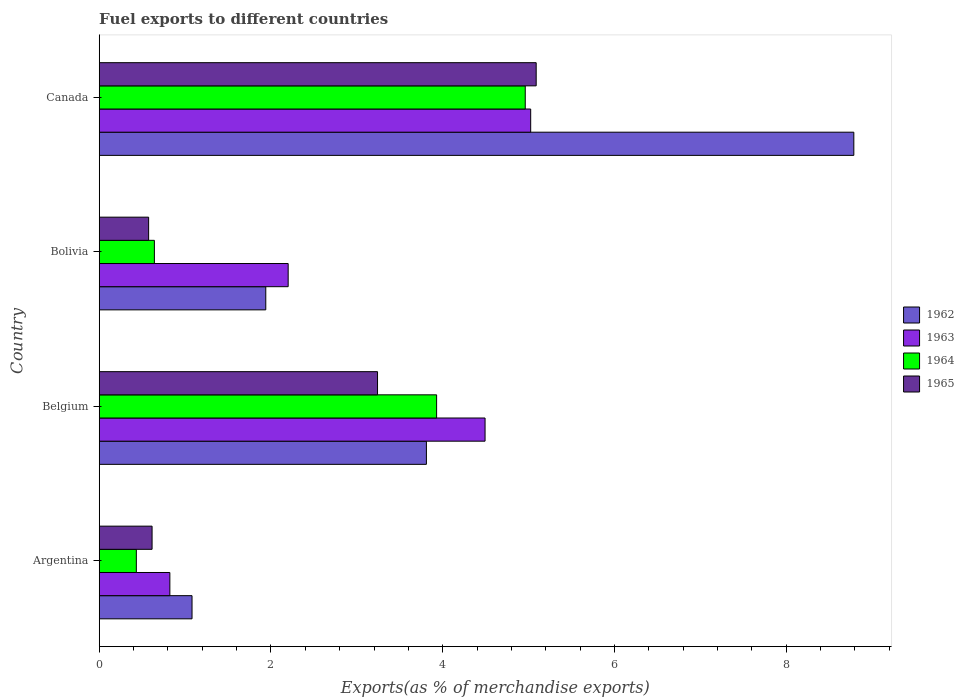How many different coloured bars are there?
Keep it short and to the point. 4. How many groups of bars are there?
Offer a very short reply. 4. Are the number of bars per tick equal to the number of legend labels?
Your answer should be compact. Yes. Are the number of bars on each tick of the Y-axis equal?
Ensure brevity in your answer.  Yes. What is the label of the 1st group of bars from the top?
Give a very brief answer. Canada. What is the percentage of exports to different countries in 1963 in Argentina?
Ensure brevity in your answer.  0.82. Across all countries, what is the maximum percentage of exports to different countries in 1962?
Keep it short and to the point. 8.79. Across all countries, what is the minimum percentage of exports to different countries in 1965?
Give a very brief answer. 0.58. In which country was the percentage of exports to different countries in 1963 minimum?
Provide a short and direct response. Argentina. What is the total percentage of exports to different countries in 1965 in the graph?
Your response must be concise. 9.52. What is the difference between the percentage of exports to different countries in 1963 in Belgium and that in Bolivia?
Your response must be concise. 2.29. What is the difference between the percentage of exports to different countries in 1963 in Bolivia and the percentage of exports to different countries in 1962 in Belgium?
Keep it short and to the point. -1.61. What is the average percentage of exports to different countries in 1962 per country?
Your answer should be very brief. 3.9. What is the difference between the percentage of exports to different countries in 1962 and percentage of exports to different countries in 1965 in Belgium?
Offer a terse response. 0.57. In how many countries, is the percentage of exports to different countries in 1962 greater than 3.2 %?
Keep it short and to the point. 2. What is the ratio of the percentage of exports to different countries in 1962 in Bolivia to that in Canada?
Your answer should be very brief. 0.22. What is the difference between the highest and the second highest percentage of exports to different countries in 1965?
Provide a short and direct response. 1.85. What is the difference between the highest and the lowest percentage of exports to different countries in 1962?
Provide a succinct answer. 7.71. In how many countries, is the percentage of exports to different countries in 1963 greater than the average percentage of exports to different countries in 1963 taken over all countries?
Offer a terse response. 2. Is it the case that in every country, the sum of the percentage of exports to different countries in 1965 and percentage of exports to different countries in 1963 is greater than the sum of percentage of exports to different countries in 1962 and percentage of exports to different countries in 1964?
Offer a terse response. No. What does the 2nd bar from the top in Belgium represents?
Your answer should be very brief. 1964. What does the 4th bar from the bottom in Belgium represents?
Your answer should be very brief. 1965. Is it the case that in every country, the sum of the percentage of exports to different countries in 1964 and percentage of exports to different countries in 1965 is greater than the percentage of exports to different countries in 1962?
Your response must be concise. No. How many bars are there?
Offer a terse response. 16. Are the values on the major ticks of X-axis written in scientific E-notation?
Provide a short and direct response. No. Where does the legend appear in the graph?
Provide a succinct answer. Center right. How many legend labels are there?
Your answer should be very brief. 4. What is the title of the graph?
Give a very brief answer. Fuel exports to different countries. Does "1961" appear as one of the legend labels in the graph?
Provide a short and direct response. No. What is the label or title of the X-axis?
Offer a very short reply. Exports(as % of merchandise exports). What is the label or title of the Y-axis?
Provide a short and direct response. Country. What is the Exports(as % of merchandise exports) in 1962 in Argentina?
Your answer should be very brief. 1.08. What is the Exports(as % of merchandise exports) of 1963 in Argentina?
Your answer should be very brief. 0.82. What is the Exports(as % of merchandise exports) of 1964 in Argentina?
Make the answer very short. 0.43. What is the Exports(as % of merchandise exports) in 1965 in Argentina?
Your answer should be compact. 0.62. What is the Exports(as % of merchandise exports) of 1962 in Belgium?
Give a very brief answer. 3.81. What is the Exports(as % of merchandise exports) in 1963 in Belgium?
Offer a terse response. 4.49. What is the Exports(as % of merchandise exports) in 1964 in Belgium?
Make the answer very short. 3.93. What is the Exports(as % of merchandise exports) in 1965 in Belgium?
Make the answer very short. 3.24. What is the Exports(as % of merchandise exports) of 1962 in Bolivia?
Keep it short and to the point. 1.94. What is the Exports(as % of merchandise exports) of 1963 in Bolivia?
Offer a terse response. 2.2. What is the Exports(as % of merchandise exports) of 1964 in Bolivia?
Keep it short and to the point. 0.64. What is the Exports(as % of merchandise exports) in 1965 in Bolivia?
Offer a terse response. 0.58. What is the Exports(as % of merchandise exports) of 1962 in Canada?
Your answer should be very brief. 8.79. What is the Exports(as % of merchandise exports) of 1963 in Canada?
Your answer should be very brief. 5.02. What is the Exports(as % of merchandise exports) in 1964 in Canada?
Your answer should be very brief. 4.96. What is the Exports(as % of merchandise exports) of 1965 in Canada?
Ensure brevity in your answer.  5.09. Across all countries, what is the maximum Exports(as % of merchandise exports) of 1962?
Ensure brevity in your answer.  8.79. Across all countries, what is the maximum Exports(as % of merchandise exports) in 1963?
Offer a very short reply. 5.02. Across all countries, what is the maximum Exports(as % of merchandise exports) in 1964?
Make the answer very short. 4.96. Across all countries, what is the maximum Exports(as % of merchandise exports) of 1965?
Offer a terse response. 5.09. Across all countries, what is the minimum Exports(as % of merchandise exports) of 1962?
Give a very brief answer. 1.08. Across all countries, what is the minimum Exports(as % of merchandise exports) in 1963?
Provide a short and direct response. 0.82. Across all countries, what is the minimum Exports(as % of merchandise exports) in 1964?
Provide a short and direct response. 0.43. Across all countries, what is the minimum Exports(as % of merchandise exports) in 1965?
Provide a short and direct response. 0.58. What is the total Exports(as % of merchandise exports) in 1962 in the graph?
Make the answer very short. 15.62. What is the total Exports(as % of merchandise exports) in 1963 in the graph?
Ensure brevity in your answer.  12.54. What is the total Exports(as % of merchandise exports) of 1964 in the graph?
Your answer should be compact. 9.97. What is the total Exports(as % of merchandise exports) in 1965 in the graph?
Ensure brevity in your answer.  9.52. What is the difference between the Exports(as % of merchandise exports) in 1962 in Argentina and that in Belgium?
Keep it short and to the point. -2.73. What is the difference between the Exports(as % of merchandise exports) of 1963 in Argentina and that in Belgium?
Provide a short and direct response. -3.67. What is the difference between the Exports(as % of merchandise exports) in 1964 in Argentina and that in Belgium?
Your response must be concise. -3.5. What is the difference between the Exports(as % of merchandise exports) in 1965 in Argentina and that in Belgium?
Your answer should be compact. -2.63. What is the difference between the Exports(as % of merchandise exports) in 1962 in Argentina and that in Bolivia?
Keep it short and to the point. -0.86. What is the difference between the Exports(as % of merchandise exports) in 1963 in Argentina and that in Bolivia?
Offer a very short reply. -1.38. What is the difference between the Exports(as % of merchandise exports) in 1964 in Argentina and that in Bolivia?
Provide a short and direct response. -0.21. What is the difference between the Exports(as % of merchandise exports) of 1965 in Argentina and that in Bolivia?
Provide a short and direct response. 0.04. What is the difference between the Exports(as % of merchandise exports) of 1962 in Argentina and that in Canada?
Your answer should be compact. -7.71. What is the difference between the Exports(as % of merchandise exports) of 1963 in Argentina and that in Canada?
Give a very brief answer. -4.2. What is the difference between the Exports(as % of merchandise exports) of 1964 in Argentina and that in Canada?
Ensure brevity in your answer.  -4.53. What is the difference between the Exports(as % of merchandise exports) in 1965 in Argentina and that in Canada?
Keep it short and to the point. -4.47. What is the difference between the Exports(as % of merchandise exports) in 1962 in Belgium and that in Bolivia?
Offer a very short reply. 1.87. What is the difference between the Exports(as % of merchandise exports) in 1963 in Belgium and that in Bolivia?
Provide a succinct answer. 2.29. What is the difference between the Exports(as % of merchandise exports) in 1964 in Belgium and that in Bolivia?
Provide a short and direct response. 3.29. What is the difference between the Exports(as % of merchandise exports) of 1965 in Belgium and that in Bolivia?
Ensure brevity in your answer.  2.67. What is the difference between the Exports(as % of merchandise exports) of 1962 in Belgium and that in Canada?
Offer a terse response. -4.98. What is the difference between the Exports(as % of merchandise exports) of 1963 in Belgium and that in Canada?
Ensure brevity in your answer.  -0.53. What is the difference between the Exports(as % of merchandise exports) of 1964 in Belgium and that in Canada?
Provide a succinct answer. -1.03. What is the difference between the Exports(as % of merchandise exports) of 1965 in Belgium and that in Canada?
Give a very brief answer. -1.85. What is the difference between the Exports(as % of merchandise exports) in 1962 in Bolivia and that in Canada?
Give a very brief answer. -6.85. What is the difference between the Exports(as % of merchandise exports) in 1963 in Bolivia and that in Canada?
Offer a terse response. -2.82. What is the difference between the Exports(as % of merchandise exports) in 1964 in Bolivia and that in Canada?
Your answer should be compact. -4.32. What is the difference between the Exports(as % of merchandise exports) of 1965 in Bolivia and that in Canada?
Provide a short and direct response. -4.51. What is the difference between the Exports(as % of merchandise exports) of 1962 in Argentina and the Exports(as % of merchandise exports) of 1963 in Belgium?
Your answer should be very brief. -3.41. What is the difference between the Exports(as % of merchandise exports) in 1962 in Argentina and the Exports(as % of merchandise exports) in 1964 in Belgium?
Your answer should be very brief. -2.85. What is the difference between the Exports(as % of merchandise exports) of 1962 in Argentina and the Exports(as % of merchandise exports) of 1965 in Belgium?
Provide a short and direct response. -2.16. What is the difference between the Exports(as % of merchandise exports) of 1963 in Argentina and the Exports(as % of merchandise exports) of 1964 in Belgium?
Provide a short and direct response. -3.11. What is the difference between the Exports(as % of merchandise exports) of 1963 in Argentina and the Exports(as % of merchandise exports) of 1965 in Belgium?
Provide a succinct answer. -2.42. What is the difference between the Exports(as % of merchandise exports) in 1964 in Argentina and the Exports(as % of merchandise exports) in 1965 in Belgium?
Give a very brief answer. -2.81. What is the difference between the Exports(as % of merchandise exports) of 1962 in Argentina and the Exports(as % of merchandise exports) of 1963 in Bolivia?
Provide a short and direct response. -1.12. What is the difference between the Exports(as % of merchandise exports) of 1962 in Argentina and the Exports(as % of merchandise exports) of 1964 in Bolivia?
Offer a very short reply. 0.44. What is the difference between the Exports(as % of merchandise exports) in 1962 in Argentina and the Exports(as % of merchandise exports) in 1965 in Bolivia?
Your answer should be compact. 0.51. What is the difference between the Exports(as % of merchandise exports) in 1963 in Argentina and the Exports(as % of merchandise exports) in 1964 in Bolivia?
Provide a succinct answer. 0.18. What is the difference between the Exports(as % of merchandise exports) of 1963 in Argentina and the Exports(as % of merchandise exports) of 1965 in Bolivia?
Give a very brief answer. 0.25. What is the difference between the Exports(as % of merchandise exports) of 1964 in Argentina and the Exports(as % of merchandise exports) of 1965 in Bolivia?
Keep it short and to the point. -0.14. What is the difference between the Exports(as % of merchandise exports) in 1962 in Argentina and the Exports(as % of merchandise exports) in 1963 in Canada?
Your answer should be very brief. -3.94. What is the difference between the Exports(as % of merchandise exports) in 1962 in Argentina and the Exports(as % of merchandise exports) in 1964 in Canada?
Ensure brevity in your answer.  -3.88. What is the difference between the Exports(as % of merchandise exports) of 1962 in Argentina and the Exports(as % of merchandise exports) of 1965 in Canada?
Offer a very short reply. -4.01. What is the difference between the Exports(as % of merchandise exports) in 1963 in Argentina and the Exports(as % of merchandise exports) in 1964 in Canada?
Offer a very short reply. -4.14. What is the difference between the Exports(as % of merchandise exports) in 1963 in Argentina and the Exports(as % of merchandise exports) in 1965 in Canada?
Give a very brief answer. -4.27. What is the difference between the Exports(as % of merchandise exports) in 1964 in Argentina and the Exports(as % of merchandise exports) in 1965 in Canada?
Provide a succinct answer. -4.66. What is the difference between the Exports(as % of merchandise exports) in 1962 in Belgium and the Exports(as % of merchandise exports) in 1963 in Bolivia?
Provide a succinct answer. 1.61. What is the difference between the Exports(as % of merchandise exports) of 1962 in Belgium and the Exports(as % of merchandise exports) of 1964 in Bolivia?
Provide a short and direct response. 3.17. What is the difference between the Exports(as % of merchandise exports) in 1962 in Belgium and the Exports(as % of merchandise exports) in 1965 in Bolivia?
Your answer should be very brief. 3.23. What is the difference between the Exports(as % of merchandise exports) in 1963 in Belgium and the Exports(as % of merchandise exports) in 1964 in Bolivia?
Make the answer very short. 3.85. What is the difference between the Exports(as % of merchandise exports) of 1963 in Belgium and the Exports(as % of merchandise exports) of 1965 in Bolivia?
Offer a terse response. 3.92. What is the difference between the Exports(as % of merchandise exports) of 1964 in Belgium and the Exports(as % of merchandise exports) of 1965 in Bolivia?
Your answer should be very brief. 3.35. What is the difference between the Exports(as % of merchandise exports) in 1962 in Belgium and the Exports(as % of merchandise exports) in 1963 in Canada?
Make the answer very short. -1.21. What is the difference between the Exports(as % of merchandise exports) in 1962 in Belgium and the Exports(as % of merchandise exports) in 1964 in Canada?
Provide a succinct answer. -1.15. What is the difference between the Exports(as % of merchandise exports) in 1962 in Belgium and the Exports(as % of merchandise exports) in 1965 in Canada?
Ensure brevity in your answer.  -1.28. What is the difference between the Exports(as % of merchandise exports) in 1963 in Belgium and the Exports(as % of merchandise exports) in 1964 in Canada?
Your answer should be very brief. -0.47. What is the difference between the Exports(as % of merchandise exports) of 1963 in Belgium and the Exports(as % of merchandise exports) of 1965 in Canada?
Provide a succinct answer. -0.6. What is the difference between the Exports(as % of merchandise exports) in 1964 in Belgium and the Exports(as % of merchandise exports) in 1965 in Canada?
Keep it short and to the point. -1.16. What is the difference between the Exports(as % of merchandise exports) in 1962 in Bolivia and the Exports(as % of merchandise exports) in 1963 in Canada?
Make the answer very short. -3.08. What is the difference between the Exports(as % of merchandise exports) of 1962 in Bolivia and the Exports(as % of merchandise exports) of 1964 in Canada?
Offer a very short reply. -3.02. What is the difference between the Exports(as % of merchandise exports) in 1962 in Bolivia and the Exports(as % of merchandise exports) in 1965 in Canada?
Offer a terse response. -3.15. What is the difference between the Exports(as % of merchandise exports) in 1963 in Bolivia and the Exports(as % of merchandise exports) in 1964 in Canada?
Offer a terse response. -2.76. What is the difference between the Exports(as % of merchandise exports) of 1963 in Bolivia and the Exports(as % of merchandise exports) of 1965 in Canada?
Provide a short and direct response. -2.89. What is the difference between the Exports(as % of merchandise exports) in 1964 in Bolivia and the Exports(as % of merchandise exports) in 1965 in Canada?
Provide a succinct answer. -4.45. What is the average Exports(as % of merchandise exports) in 1962 per country?
Offer a very short reply. 3.9. What is the average Exports(as % of merchandise exports) of 1963 per country?
Offer a very short reply. 3.14. What is the average Exports(as % of merchandise exports) in 1964 per country?
Make the answer very short. 2.49. What is the average Exports(as % of merchandise exports) in 1965 per country?
Make the answer very short. 2.38. What is the difference between the Exports(as % of merchandise exports) of 1962 and Exports(as % of merchandise exports) of 1963 in Argentina?
Offer a terse response. 0.26. What is the difference between the Exports(as % of merchandise exports) of 1962 and Exports(as % of merchandise exports) of 1964 in Argentina?
Your response must be concise. 0.65. What is the difference between the Exports(as % of merchandise exports) of 1962 and Exports(as % of merchandise exports) of 1965 in Argentina?
Provide a short and direct response. 0.47. What is the difference between the Exports(as % of merchandise exports) in 1963 and Exports(as % of merchandise exports) in 1964 in Argentina?
Provide a succinct answer. 0.39. What is the difference between the Exports(as % of merchandise exports) in 1963 and Exports(as % of merchandise exports) in 1965 in Argentina?
Your answer should be very brief. 0.21. What is the difference between the Exports(as % of merchandise exports) of 1964 and Exports(as % of merchandise exports) of 1965 in Argentina?
Keep it short and to the point. -0.18. What is the difference between the Exports(as % of merchandise exports) in 1962 and Exports(as % of merchandise exports) in 1963 in Belgium?
Offer a terse response. -0.68. What is the difference between the Exports(as % of merchandise exports) in 1962 and Exports(as % of merchandise exports) in 1964 in Belgium?
Keep it short and to the point. -0.12. What is the difference between the Exports(as % of merchandise exports) in 1962 and Exports(as % of merchandise exports) in 1965 in Belgium?
Provide a succinct answer. 0.57. What is the difference between the Exports(as % of merchandise exports) of 1963 and Exports(as % of merchandise exports) of 1964 in Belgium?
Provide a succinct answer. 0.56. What is the difference between the Exports(as % of merchandise exports) of 1963 and Exports(as % of merchandise exports) of 1965 in Belgium?
Your answer should be compact. 1.25. What is the difference between the Exports(as % of merchandise exports) in 1964 and Exports(as % of merchandise exports) in 1965 in Belgium?
Your response must be concise. 0.69. What is the difference between the Exports(as % of merchandise exports) of 1962 and Exports(as % of merchandise exports) of 1963 in Bolivia?
Offer a terse response. -0.26. What is the difference between the Exports(as % of merchandise exports) of 1962 and Exports(as % of merchandise exports) of 1964 in Bolivia?
Give a very brief answer. 1.3. What is the difference between the Exports(as % of merchandise exports) of 1962 and Exports(as % of merchandise exports) of 1965 in Bolivia?
Offer a terse response. 1.36. What is the difference between the Exports(as % of merchandise exports) in 1963 and Exports(as % of merchandise exports) in 1964 in Bolivia?
Your response must be concise. 1.56. What is the difference between the Exports(as % of merchandise exports) in 1963 and Exports(as % of merchandise exports) in 1965 in Bolivia?
Ensure brevity in your answer.  1.62. What is the difference between the Exports(as % of merchandise exports) of 1964 and Exports(as % of merchandise exports) of 1965 in Bolivia?
Your answer should be very brief. 0.07. What is the difference between the Exports(as % of merchandise exports) in 1962 and Exports(as % of merchandise exports) in 1963 in Canada?
Your response must be concise. 3.76. What is the difference between the Exports(as % of merchandise exports) in 1962 and Exports(as % of merchandise exports) in 1964 in Canada?
Provide a short and direct response. 3.83. What is the difference between the Exports(as % of merchandise exports) in 1962 and Exports(as % of merchandise exports) in 1965 in Canada?
Your answer should be compact. 3.7. What is the difference between the Exports(as % of merchandise exports) in 1963 and Exports(as % of merchandise exports) in 1964 in Canada?
Ensure brevity in your answer.  0.06. What is the difference between the Exports(as % of merchandise exports) in 1963 and Exports(as % of merchandise exports) in 1965 in Canada?
Offer a very short reply. -0.06. What is the difference between the Exports(as % of merchandise exports) of 1964 and Exports(as % of merchandise exports) of 1965 in Canada?
Your answer should be compact. -0.13. What is the ratio of the Exports(as % of merchandise exports) in 1962 in Argentina to that in Belgium?
Keep it short and to the point. 0.28. What is the ratio of the Exports(as % of merchandise exports) of 1963 in Argentina to that in Belgium?
Your response must be concise. 0.18. What is the ratio of the Exports(as % of merchandise exports) of 1964 in Argentina to that in Belgium?
Your answer should be very brief. 0.11. What is the ratio of the Exports(as % of merchandise exports) of 1965 in Argentina to that in Belgium?
Provide a succinct answer. 0.19. What is the ratio of the Exports(as % of merchandise exports) in 1962 in Argentina to that in Bolivia?
Keep it short and to the point. 0.56. What is the ratio of the Exports(as % of merchandise exports) in 1963 in Argentina to that in Bolivia?
Make the answer very short. 0.37. What is the ratio of the Exports(as % of merchandise exports) of 1964 in Argentina to that in Bolivia?
Offer a very short reply. 0.67. What is the ratio of the Exports(as % of merchandise exports) of 1965 in Argentina to that in Bolivia?
Your response must be concise. 1.07. What is the ratio of the Exports(as % of merchandise exports) of 1962 in Argentina to that in Canada?
Ensure brevity in your answer.  0.12. What is the ratio of the Exports(as % of merchandise exports) in 1963 in Argentina to that in Canada?
Provide a short and direct response. 0.16. What is the ratio of the Exports(as % of merchandise exports) in 1964 in Argentina to that in Canada?
Offer a very short reply. 0.09. What is the ratio of the Exports(as % of merchandise exports) of 1965 in Argentina to that in Canada?
Your answer should be very brief. 0.12. What is the ratio of the Exports(as % of merchandise exports) in 1962 in Belgium to that in Bolivia?
Make the answer very short. 1.96. What is the ratio of the Exports(as % of merchandise exports) of 1963 in Belgium to that in Bolivia?
Your answer should be very brief. 2.04. What is the ratio of the Exports(as % of merchandise exports) of 1964 in Belgium to that in Bolivia?
Provide a succinct answer. 6.12. What is the ratio of the Exports(as % of merchandise exports) of 1965 in Belgium to that in Bolivia?
Give a very brief answer. 5.63. What is the ratio of the Exports(as % of merchandise exports) of 1962 in Belgium to that in Canada?
Provide a succinct answer. 0.43. What is the ratio of the Exports(as % of merchandise exports) of 1963 in Belgium to that in Canada?
Provide a short and direct response. 0.89. What is the ratio of the Exports(as % of merchandise exports) of 1964 in Belgium to that in Canada?
Offer a terse response. 0.79. What is the ratio of the Exports(as % of merchandise exports) in 1965 in Belgium to that in Canada?
Provide a succinct answer. 0.64. What is the ratio of the Exports(as % of merchandise exports) of 1962 in Bolivia to that in Canada?
Ensure brevity in your answer.  0.22. What is the ratio of the Exports(as % of merchandise exports) of 1963 in Bolivia to that in Canada?
Your answer should be compact. 0.44. What is the ratio of the Exports(as % of merchandise exports) in 1964 in Bolivia to that in Canada?
Provide a short and direct response. 0.13. What is the ratio of the Exports(as % of merchandise exports) of 1965 in Bolivia to that in Canada?
Make the answer very short. 0.11. What is the difference between the highest and the second highest Exports(as % of merchandise exports) in 1962?
Offer a terse response. 4.98. What is the difference between the highest and the second highest Exports(as % of merchandise exports) of 1963?
Your answer should be very brief. 0.53. What is the difference between the highest and the second highest Exports(as % of merchandise exports) of 1964?
Offer a terse response. 1.03. What is the difference between the highest and the second highest Exports(as % of merchandise exports) of 1965?
Offer a terse response. 1.85. What is the difference between the highest and the lowest Exports(as % of merchandise exports) of 1962?
Your response must be concise. 7.71. What is the difference between the highest and the lowest Exports(as % of merchandise exports) of 1963?
Make the answer very short. 4.2. What is the difference between the highest and the lowest Exports(as % of merchandise exports) of 1964?
Offer a very short reply. 4.53. What is the difference between the highest and the lowest Exports(as % of merchandise exports) of 1965?
Your answer should be very brief. 4.51. 